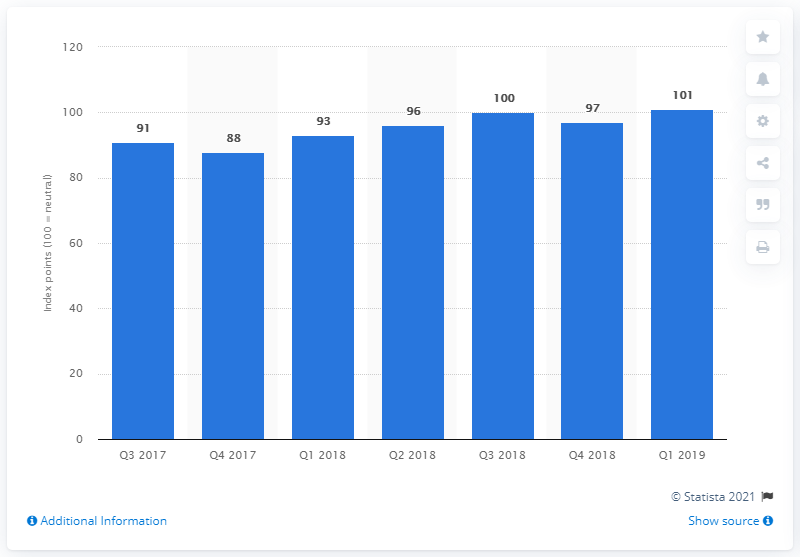Point out several critical features in this image. The consumer confidence index in Mexico during the first quarter of 2019 was 101. 